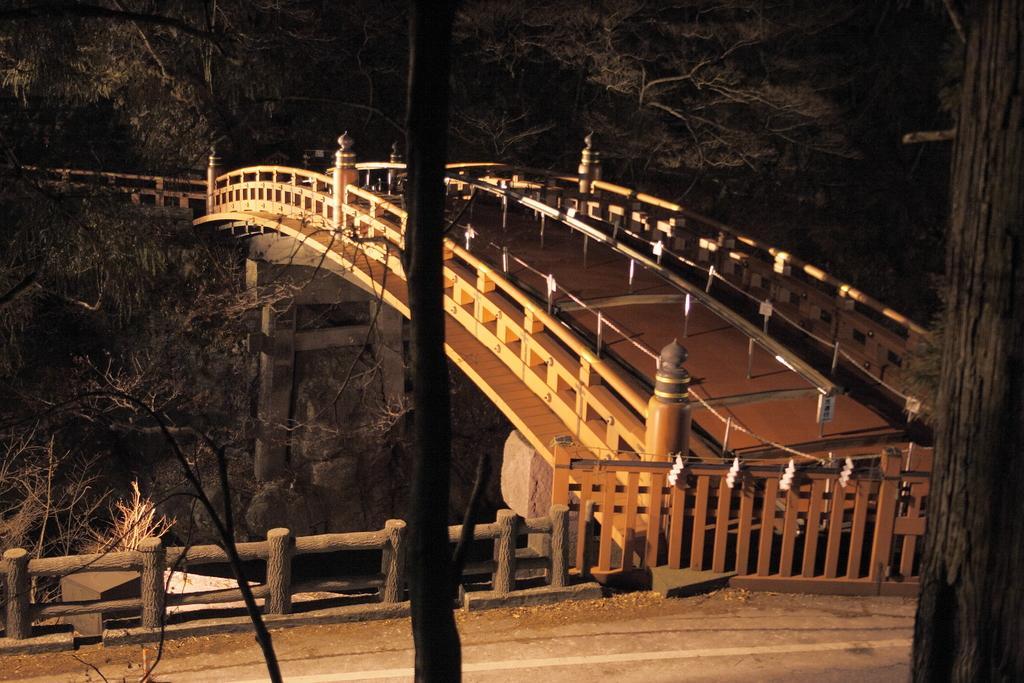Describe this image in one or two sentences. This image consists of bridge in the middle. There are trees at the top and middle. 